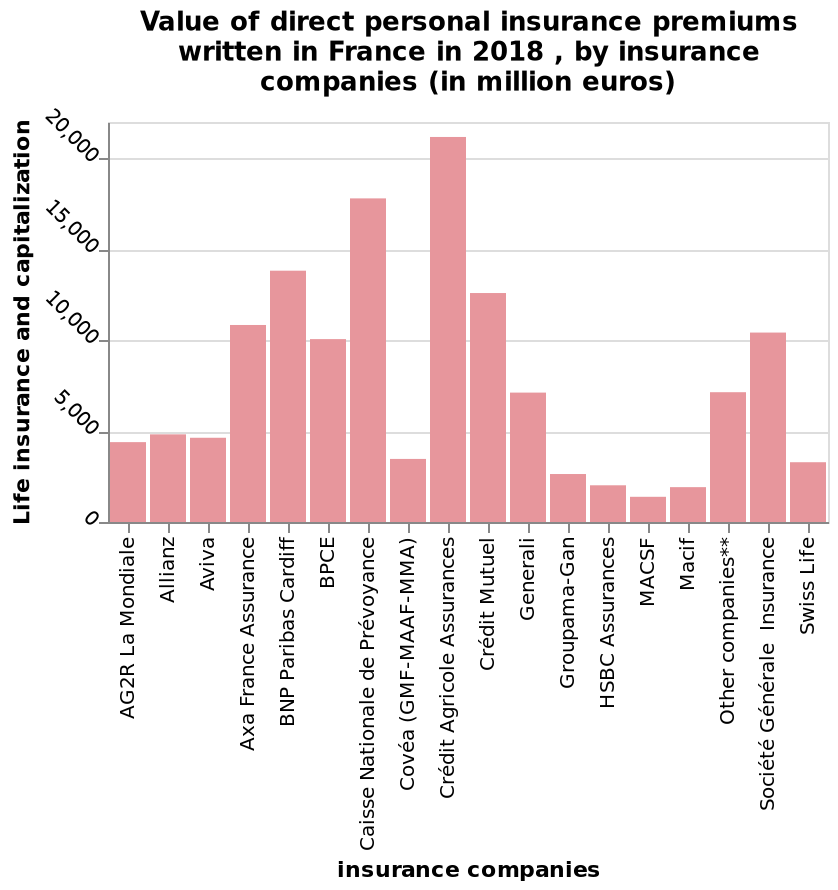<image>
Did all insurance providers see a value of under 500 million euros? It is not specified whether all insurance providers saw a value of under 500 million euros.  What is the unit of measurement for the values on the bar chart? The unit of measurement for the values on the bar chart is million euros. Which axis of the bar chart represents the insurance companies? The x-axis represents the insurance companies. 